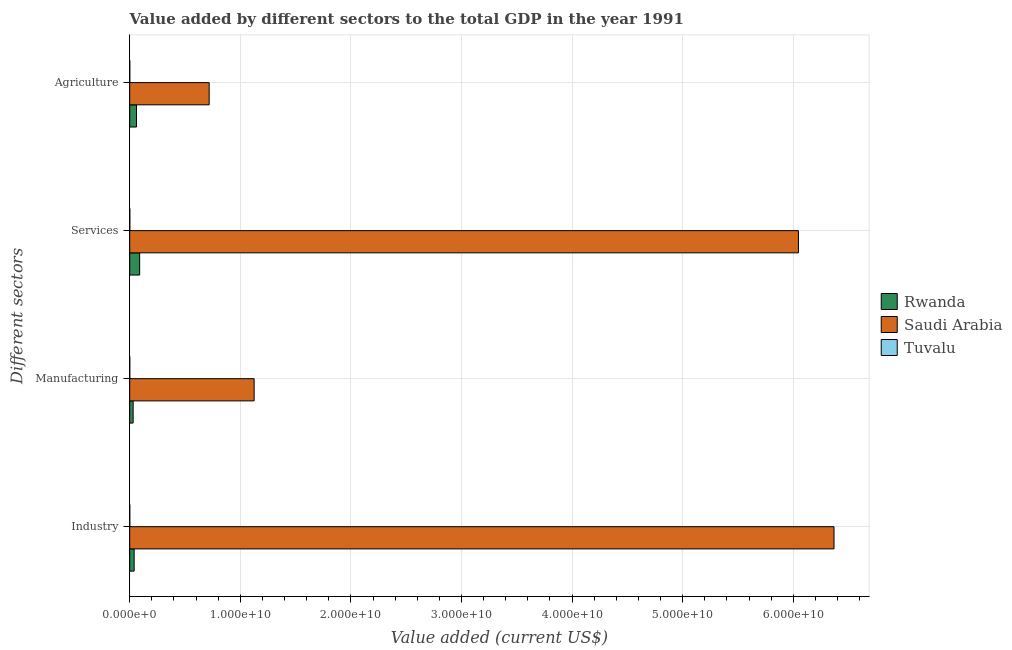How many groups of bars are there?
Give a very brief answer. 4. Are the number of bars on each tick of the Y-axis equal?
Keep it short and to the point. Yes. How many bars are there on the 2nd tick from the bottom?
Keep it short and to the point. 3. What is the label of the 3rd group of bars from the top?
Give a very brief answer. Manufacturing. What is the value added by manufacturing sector in Tuvalu?
Your answer should be very brief. 3.01e+05. Across all countries, what is the maximum value added by agricultural sector?
Your response must be concise. 7.18e+09. Across all countries, what is the minimum value added by services sector?
Make the answer very short. 5.72e+06. In which country was the value added by agricultural sector maximum?
Offer a terse response. Saudi Arabia. In which country was the value added by services sector minimum?
Ensure brevity in your answer.  Tuvalu. What is the total value added by services sector in the graph?
Offer a very short reply. 6.14e+1. What is the difference between the value added by services sector in Tuvalu and that in Saudi Arabia?
Your response must be concise. -6.05e+1. What is the difference between the value added by services sector in Rwanda and the value added by manufacturing sector in Tuvalu?
Offer a very short reply. 8.97e+08. What is the average value added by manufacturing sector per country?
Provide a short and direct response. 3.85e+09. What is the difference between the value added by services sector and value added by agricultural sector in Tuvalu?
Give a very brief answer. 3.46e+06. In how many countries, is the value added by services sector greater than 32000000000 US$?
Ensure brevity in your answer.  1. What is the ratio of the value added by manufacturing sector in Saudi Arabia to that in Rwanda?
Your answer should be very brief. 36.47. Is the value added by agricultural sector in Rwanda less than that in Tuvalu?
Make the answer very short. No. What is the difference between the highest and the second highest value added by industrial sector?
Your response must be concise. 6.33e+1. What is the difference between the highest and the lowest value added by agricultural sector?
Provide a succinct answer. 7.18e+09. Is it the case that in every country, the sum of the value added by services sector and value added by industrial sector is greater than the sum of value added by manufacturing sector and value added by agricultural sector?
Offer a terse response. No. What does the 3rd bar from the top in Manufacturing represents?
Give a very brief answer. Rwanda. What does the 1st bar from the bottom in Services represents?
Offer a terse response. Rwanda. Is it the case that in every country, the sum of the value added by industrial sector and value added by manufacturing sector is greater than the value added by services sector?
Your answer should be very brief. No. How many bars are there?
Give a very brief answer. 12. Are all the bars in the graph horizontal?
Make the answer very short. Yes. How many countries are there in the graph?
Your response must be concise. 3. Are the values on the major ticks of X-axis written in scientific E-notation?
Provide a short and direct response. Yes. Does the graph contain grids?
Keep it short and to the point. Yes. How are the legend labels stacked?
Provide a short and direct response. Vertical. What is the title of the graph?
Make the answer very short. Value added by different sectors to the total GDP in the year 1991. Does "Middle income" appear as one of the legend labels in the graph?
Your response must be concise. No. What is the label or title of the X-axis?
Provide a succinct answer. Value added (current US$). What is the label or title of the Y-axis?
Make the answer very short. Different sectors. What is the Value added (current US$) of Rwanda in Industry?
Your answer should be compact. 4.00e+08. What is the Value added (current US$) of Saudi Arabia in Industry?
Offer a terse response. 6.37e+1. What is the Value added (current US$) in Tuvalu in Industry?
Your response must be concise. 1.38e+06. What is the Value added (current US$) of Rwanda in Manufacturing?
Make the answer very short. 3.09e+08. What is the Value added (current US$) of Saudi Arabia in Manufacturing?
Offer a terse response. 1.13e+1. What is the Value added (current US$) of Tuvalu in Manufacturing?
Provide a short and direct response. 3.01e+05. What is the Value added (current US$) in Rwanda in Services?
Give a very brief answer. 8.97e+08. What is the Value added (current US$) of Saudi Arabia in Services?
Give a very brief answer. 6.05e+1. What is the Value added (current US$) in Tuvalu in Services?
Provide a succinct answer. 5.72e+06. What is the Value added (current US$) of Rwanda in Agriculture?
Provide a short and direct response. 6.14e+08. What is the Value added (current US$) of Saudi Arabia in Agriculture?
Ensure brevity in your answer.  7.18e+09. What is the Value added (current US$) in Tuvalu in Agriculture?
Provide a succinct answer. 2.26e+06. Across all Different sectors, what is the maximum Value added (current US$) of Rwanda?
Provide a short and direct response. 8.97e+08. Across all Different sectors, what is the maximum Value added (current US$) of Saudi Arabia?
Make the answer very short. 6.37e+1. Across all Different sectors, what is the maximum Value added (current US$) of Tuvalu?
Keep it short and to the point. 5.72e+06. Across all Different sectors, what is the minimum Value added (current US$) of Rwanda?
Offer a very short reply. 3.09e+08. Across all Different sectors, what is the minimum Value added (current US$) in Saudi Arabia?
Offer a terse response. 7.18e+09. Across all Different sectors, what is the minimum Value added (current US$) of Tuvalu?
Ensure brevity in your answer.  3.01e+05. What is the total Value added (current US$) of Rwanda in the graph?
Offer a very short reply. 2.22e+09. What is the total Value added (current US$) in Saudi Arabia in the graph?
Your answer should be compact. 1.43e+11. What is the total Value added (current US$) of Tuvalu in the graph?
Make the answer very short. 9.67e+06. What is the difference between the Value added (current US$) in Rwanda in Industry and that in Manufacturing?
Provide a short and direct response. 9.18e+07. What is the difference between the Value added (current US$) of Saudi Arabia in Industry and that in Manufacturing?
Your answer should be compact. 5.24e+1. What is the difference between the Value added (current US$) of Tuvalu in Industry and that in Manufacturing?
Give a very brief answer. 1.08e+06. What is the difference between the Value added (current US$) in Rwanda in Industry and that in Services?
Your response must be concise. -4.97e+08. What is the difference between the Value added (current US$) in Saudi Arabia in Industry and that in Services?
Keep it short and to the point. 3.22e+09. What is the difference between the Value added (current US$) of Tuvalu in Industry and that in Services?
Your answer should be very brief. -4.34e+06. What is the difference between the Value added (current US$) of Rwanda in Industry and that in Agriculture?
Your response must be concise. -2.14e+08. What is the difference between the Value added (current US$) in Saudi Arabia in Industry and that in Agriculture?
Offer a terse response. 5.65e+1. What is the difference between the Value added (current US$) of Tuvalu in Industry and that in Agriculture?
Offer a very short reply. -8.85e+05. What is the difference between the Value added (current US$) of Rwanda in Manufacturing and that in Services?
Provide a succinct answer. -5.89e+08. What is the difference between the Value added (current US$) of Saudi Arabia in Manufacturing and that in Services?
Your answer should be compact. -4.92e+1. What is the difference between the Value added (current US$) of Tuvalu in Manufacturing and that in Services?
Make the answer very short. -5.42e+06. What is the difference between the Value added (current US$) of Rwanda in Manufacturing and that in Agriculture?
Offer a very short reply. -3.06e+08. What is the difference between the Value added (current US$) of Saudi Arabia in Manufacturing and that in Agriculture?
Provide a succinct answer. 4.07e+09. What is the difference between the Value added (current US$) in Tuvalu in Manufacturing and that in Agriculture?
Provide a short and direct response. -1.96e+06. What is the difference between the Value added (current US$) of Rwanda in Services and that in Agriculture?
Your answer should be compact. 2.83e+08. What is the difference between the Value added (current US$) of Saudi Arabia in Services and that in Agriculture?
Keep it short and to the point. 5.33e+1. What is the difference between the Value added (current US$) in Tuvalu in Services and that in Agriculture?
Offer a terse response. 3.46e+06. What is the difference between the Value added (current US$) in Rwanda in Industry and the Value added (current US$) in Saudi Arabia in Manufacturing?
Your answer should be very brief. -1.09e+1. What is the difference between the Value added (current US$) of Rwanda in Industry and the Value added (current US$) of Tuvalu in Manufacturing?
Give a very brief answer. 4.00e+08. What is the difference between the Value added (current US$) of Saudi Arabia in Industry and the Value added (current US$) of Tuvalu in Manufacturing?
Ensure brevity in your answer.  6.37e+1. What is the difference between the Value added (current US$) of Rwanda in Industry and the Value added (current US$) of Saudi Arabia in Services?
Keep it short and to the point. -6.01e+1. What is the difference between the Value added (current US$) of Rwanda in Industry and the Value added (current US$) of Tuvalu in Services?
Provide a succinct answer. 3.95e+08. What is the difference between the Value added (current US$) in Saudi Arabia in Industry and the Value added (current US$) in Tuvalu in Services?
Make the answer very short. 6.37e+1. What is the difference between the Value added (current US$) of Rwanda in Industry and the Value added (current US$) of Saudi Arabia in Agriculture?
Offer a very short reply. -6.78e+09. What is the difference between the Value added (current US$) in Rwanda in Industry and the Value added (current US$) in Tuvalu in Agriculture?
Your answer should be compact. 3.98e+08. What is the difference between the Value added (current US$) of Saudi Arabia in Industry and the Value added (current US$) of Tuvalu in Agriculture?
Keep it short and to the point. 6.37e+1. What is the difference between the Value added (current US$) of Rwanda in Manufacturing and the Value added (current US$) of Saudi Arabia in Services?
Ensure brevity in your answer.  -6.02e+1. What is the difference between the Value added (current US$) in Rwanda in Manufacturing and the Value added (current US$) in Tuvalu in Services?
Your answer should be very brief. 3.03e+08. What is the difference between the Value added (current US$) in Saudi Arabia in Manufacturing and the Value added (current US$) in Tuvalu in Services?
Keep it short and to the point. 1.12e+1. What is the difference between the Value added (current US$) in Rwanda in Manufacturing and the Value added (current US$) in Saudi Arabia in Agriculture?
Your answer should be very brief. -6.87e+09. What is the difference between the Value added (current US$) of Rwanda in Manufacturing and the Value added (current US$) of Tuvalu in Agriculture?
Offer a terse response. 3.06e+08. What is the difference between the Value added (current US$) in Saudi Arabia in Manufacturing and the Value added (current US$) in Tuvalu in Agriculture?
Offer a very short reply. 1.12e+1. What is the difference between the Value added (current US$) in Rwanda in Services and the Value added (current US$) in Saudi Arabia in Agriculture?
Keep it short and to the point. -6.29e+09. What is the difference between the Value added (current US$) of Rwanda in Services and the Value added (current US$) of Tuvalu in Agriculture?
Make the answer very short. 8.95e+08. What is the difference between the Value added (current US$) in Saudi Arabia in Services and the Value added (current US$) in Tuvalu in Agriculture?
Your response must be concise. 6.05e+1. What is the average Value added (current US$) in Rwanda per Different sectors?
Give a very brief answer. 5.55e+08. What is the average Value added (current US$) of Saudi Arabia per Different sectors?
Give a very brief answer. 3.56e+1. What is the average Value added (current US$) of Tuvalu per Different sectors?
Your answer should be compact. 2.42e+06. What is the difference between the Value added (current US$) of Rwanda and Value added (current US$) of Saudi Arabia in Industry?
Ensure brevity in your answer.  -6.33e+1. What is the difference between the Value added (current US$) in Rwanda and Value added (current US$) in Tuvalu in Industry?
Give a very brief answer. 3.99e+08. What is the difference between the Value added (current US$) of Saudi Arabia and Value added (current US$) of Tuvalu in Industry?
Your answer should be very brief. 6.37e+1. What is the difference between the Value added (current US$) in Rwanda and Value added (current US$) in Saudi Arabia in Manufacturing?
Provide a succinct answer. -1.09e+1. What is the difference between the Value added (current US$) of Rwanda and Value added (current US$) of Tuvalu in Manufacturing?
Give a very brief answer. 3.08e+08. What is the difference between the Value added (current US$) of Saudi Arabia and Value added (current US$) of Tuvalu in Manufacturing?
Your answer should be compact. 1.13e+1. What is the difference between the Value added (current US$) in Rwanda and Value added (current US$) in Saudi Arabia in Services?
Your answer should be very brief. -5.96e+1. What is the difference between the Value added (current US$) of Rwanda and Value added (current US$) of Tuvalu in Services?
Offer a terse response. 8.91e+08. What is the difference between the Value added (current US$) in Saudi Arabia and Value added (current US$) in Tuvalu in Services?
Offer a terse response. 6.05e+1. What is the difference between the Value added (current US$) in Rwanda and Value added (current US$) in Saudi Arabia in Agriculture?
Offer a very short reply. -6.57e+09. What is the difference between the Value added (current US$) of Rwanda and Value added (current US$) of Tuvalu in Agriculture?
Offer a terse response. 6.12e+08. What is the difference between the Value added (current US$) of Saudi Arabia and Value added (current US$) of Tuvalu in Agriculture?
Offer a very short reply. 7.18e+09. What is the ratio of the Value added (current US$) of Rwanda in Industry to that in Manufacturing?
Give a very brief answer. 1.3. What is the ratio of the Value added (current US$) of Saudi Arabia in Industry to that in Manufacturing?
Your response must be concise. 5.66. What is the ratio of the Value added (current US$) of Tuvalu in Industry to that in Manufacturing?
Ensure brevity in your answer.  4.59. What is the ratio of the Value added (current US$) in Rwanda in Industry to that in Services?
Provide a short and direct response. 0.45. What is the ratio of the Value added (current US$) in Saudi Arabia in Industry to that in Services?
Your answer should be very brief. 1.05. What is the ratio of the Value added (current US$) of Tuvalu in Industry to that in Services?
Ensure brevity in your answer.  0.24. What is the ratio of the Value added (current US$) in Rwanda in Industry to that in Agriculture?
Provide a succinct answer. 0.65. What is the ratio of the Value added (current US$) of Saudi Arabia in Industry to that in Agriculture?
Offer a very short reply. 8.87. What is the ratio of the Value added (current US$) of Tuvalu in Industry to that in Agriculture?
Ensure brevity in your answer.  0.61. What is the ratio of the Value added (current US$) of Rwanda in Manufacturing to that in Services?
Provide a short and direct response. 0.34. What is the ratio of the Value added (current US$) of Saudi Arabia in Manufacturing to that in Services?
Ensure brevity in your answer.  0.19. What is the ratio of the Value added (current US$) in Tuvalu in Manufacturing to that in Services?
Your answer should be very brief. 0.05. What is the ratio of the Value added (current US$) in Rwanda in Manufacturing to that in Agriculture?
Make the answer very short. 0.5. What is the ratio of the Value added (current US$) of Saudi Arabia in Manufacturing to that in Agriculture?
Offer a terse response. 1.57. What is the ratio of the Value added (current US$) in Tuvalu in Manufacturing to that in Agriculture?
Offer a terse response. 0.13. What is the ratio of the Value added (current US$) of Rwanda in Services to that in Agriculture?
Keep it short and to the point. 1.46. What is the ratio of the Value added (current US$) in Saudi Arabia in Services to that in Agriculture?
Your response must be concise. 8.42. What is the ratio of the Value added (current US$) in Tuvalu in Services to that in Agriculture?
Your answer should be very brief. 2.53. What is the difference between the highest and the second highest Value added (current US$) in Rwanda?
Ensure brevity in your answer.  2.83e+08. What is the difference between the highest and the second highest Value added (current US$) in Saudi Arabia?
Provide a short and direct response. 3.22e+09. What is the difference between the highest and the second highest Value added (current US$) in Tuvalu?
Your answer should be compact. 3.46e+06. What is the difference between the highest and the lowest Value added (current US$) of Rwanda?
Offer a very short reply. 5.89e+08. What is the difference between the highest and the lowest Value added (current US$) in Saudi Arabia?
Provide a short and direct response. 5.65e+1. What is the difference between the highest and the lowest Value added (current US$) in Tuvalu?
Your answer should be compact. 5.42e+06. 